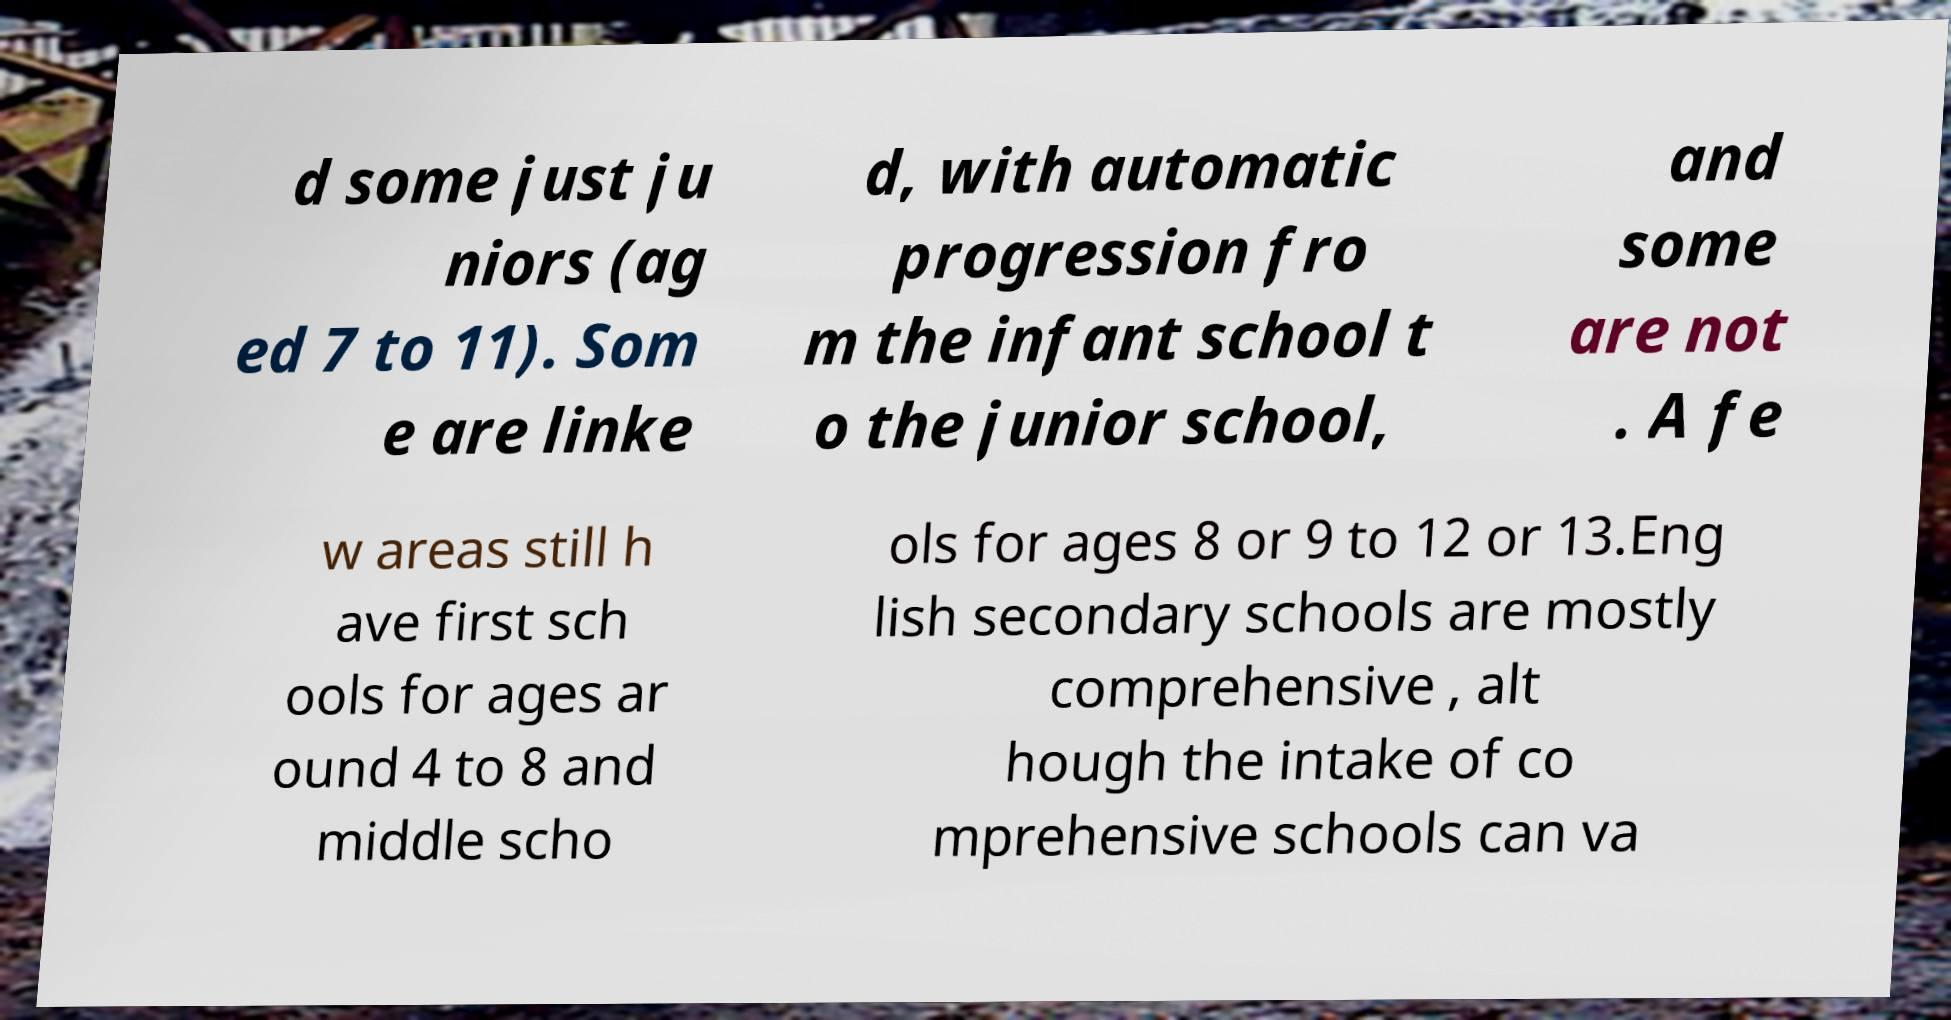Can you accurately transcribe the text from the provided image for me? d some just ju niors (ag ed 7 to 11). Som e are linke d, with automatic progression fro m the infant school t o the junior school, and some are not . A fe w areas still h ave first sch ools for ages ar ound 4 to 8 and middle scho ols for ages 8 or 9 to 12 or 13.Eng lish secondary schools are mostly comprehensive , alt hough the intake of co mprehensive schools can va 